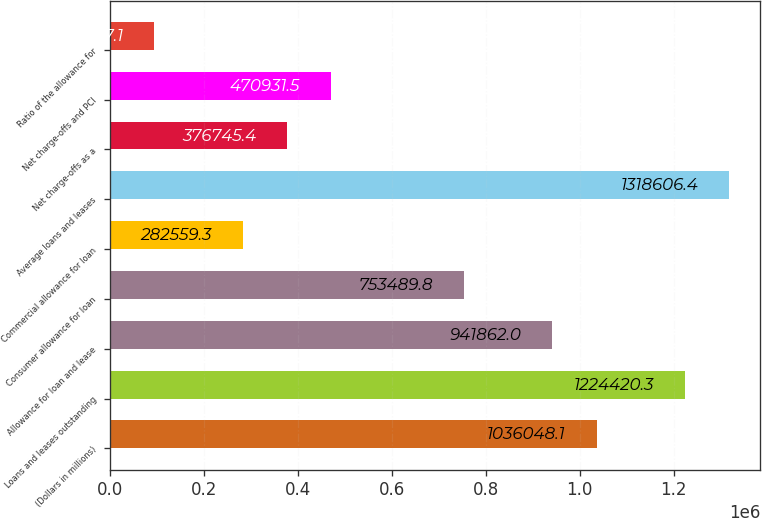Convert chart to OTSL. <chart><loc_0><loc_0><loc_500><loc_500><bar_chart><fcel>(Dollars in millions)<fcel>Loans and leases outstanding<fcel>Allowance for loan and lease<fcel>Consumer allowance for loan<fcel>Commercial allowance for loan<fcel>Average loans and leases<fcel>Net charge-offs as a<fcel>Net charge-offs and PCI<fcel>Ratio of the allowance for<nl><fcel>1.03605e+06<fcel>1.22442e+06<fcel>941862<fcel>753490<fcel>282559<fcel>1.31861e+06<fcel>376745<fcel>470932<fcel>94187.1<nl></chart> 